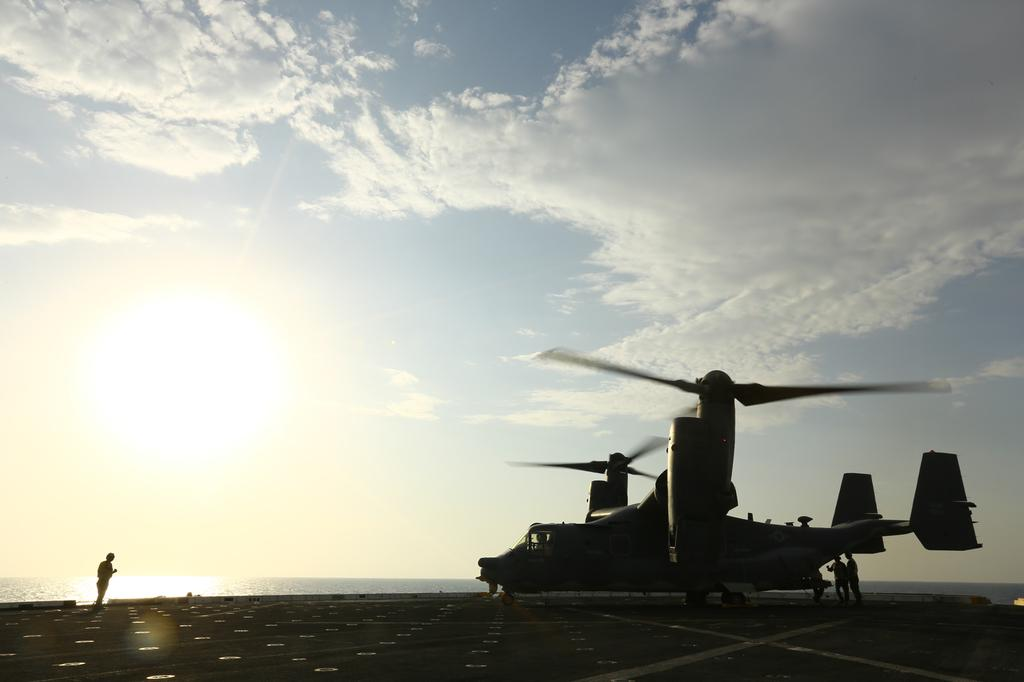How many people are in the image? There are people in the image, but the exact number is not specified. What type of vehicle is in the image? There is a helicopter in the image. Where is the helicopter located? The helicopter is on a ship. What is the ship situated on? The ship is on water. What time of day is it in the image, and how does the seashore look? The provided facts do not mention the time of day or the presence of a seashore in the image. How long does it take for the minute hand to move one minute on the helicopter's clock in the image? There is no clock visible on the helicopter in the image, so it is not possible to determine the movement of the minute hand. 